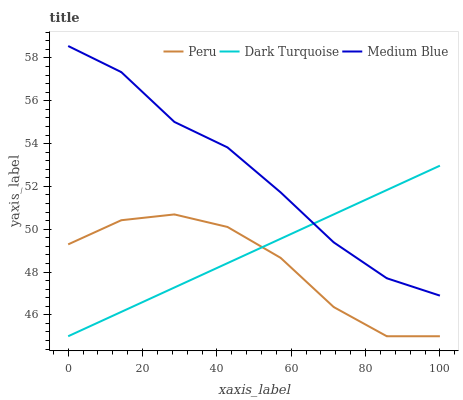Does Peru have the minimum area under the curve?
Answer yes or no. Yes. Does Medium Blue have the maximum area under the curve?
Answer yes or no. Yes. Does Medium Blue have the minimum area under the curve?
Answer yes or no. No. Does Peru have the maximum area under the curve?
Answer yes or no. No. Is Dark Turquoise the smoothest?
Answer yes or no. Yes. Is Peru the roughest?
Answer yes or no. Yes. Is Medium Blue the smoothest?
Answer yes or no. No. Is Medium Blue the roughest?
Answer yes or no. No. Does Medium Blue have the lowest value?
Answer yes or no. No. Does Medium Blue have the highest value?
Answer yes or no. Yes. Does Peru have the highest value?
Answer yes or no. No. Is Peru less than Medium Blue?
Answer yes or no. Yes. Is Medium Blue greater than Peru?
Answer yes or no. Yes. Does Dark Turquoise intersect Medium Blue?
Answer yes or no. Yes. Is Dark Turquoise less than Medium Blue?
Answer yes or no. No. Is Dark Turquoise greater than Medium Blue?
Answer yes or no. No. Does Peru intersect Medium Blue?
Answer yes or no. No. 